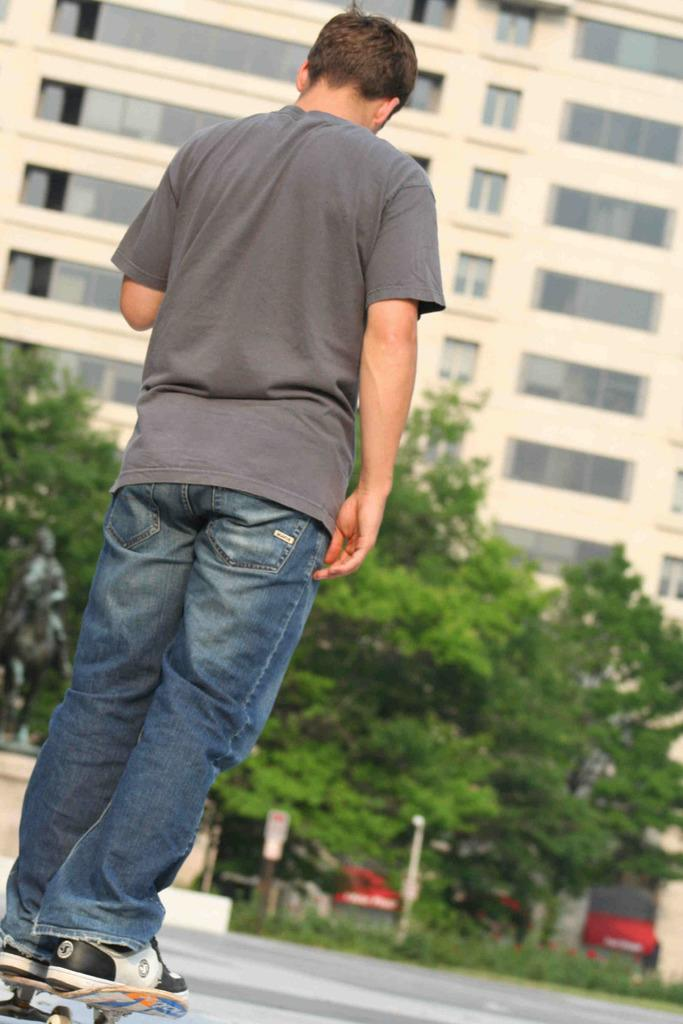What is the man in the image doing? The man is standing on a skateboard. What can be seen in the background of the image? There are trees, buildings, and grass in the background of the image. What type of rifle is the man holding in the image? There is no rifle present in the image; the man is standing on a skateboard. What kind of plant is growing in the grassy patch in the image? There is no grassy patch or plant mentioned in the image; it only features trees, buildings, and grass in the background. 